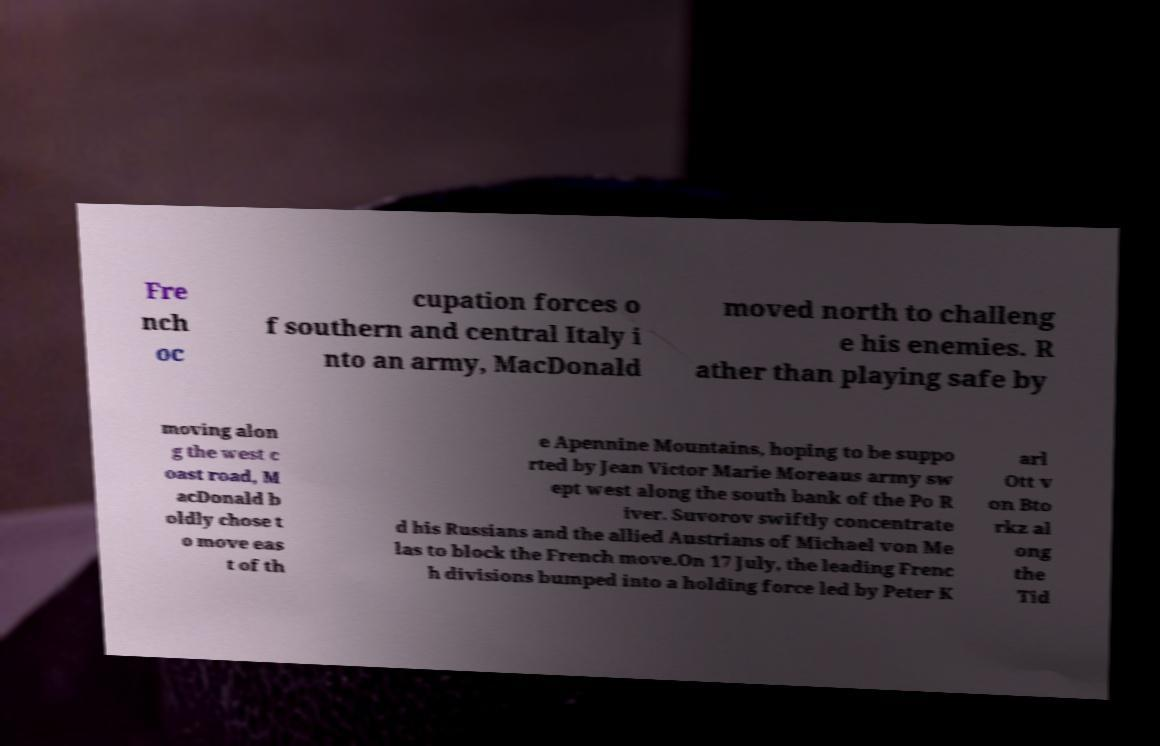For documentation purposes, I need the text within this image transcribed. Could you provide that? Fre nch oc cupation forces o f southern and central Italy i nto an army, MacDonald moved north to challeng e his enemies. R ather than playing safe by moving alon g the west c oast road, M acDonald b oldly chose t o move eas t of th e Apennine Mountains, hoping to be suppo rted by Jean Victor Marie Moreaus army sw ept west along the south bank of the Po R iver. Suvorov swiftly concentrate d his Russians and the allied Austrians of Michael von Me las to block the French move.On 17 July, the leading Frenc h divisions bumped into a holding force led by Peter K arl Ott v on Bto rkz al ong the Tid 